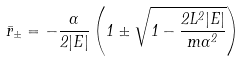<formula> <loc_0><loc_0><loc_500><loc_500>\bar { r } _ { \pm } = - \frac { \alpha } { 2 | E | } \left ( 1 \pm \sqrt { 1 - \frac { 2 L ^ { 2 } | E | } { m \alpha ^ { 2 } } } \right )</formula> 